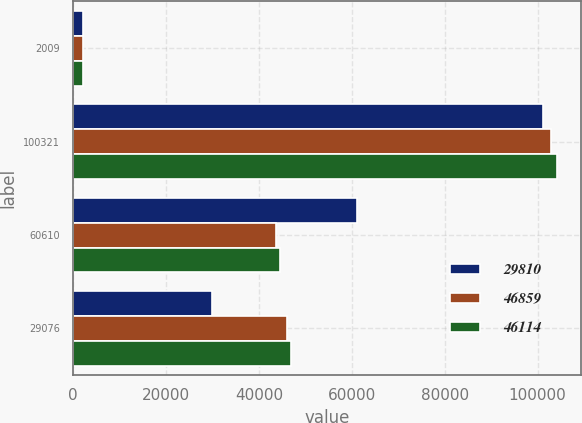Convert chart. <chart><loc_0><loc_0><loc_500><loc_500><stacked_bar_chart><ecel><fcel>2009<fcel>100321<fcel>60610<fcel>29076<nl><fcel>29810<fcel>2009<fcel>101096<fcel>61121<fcel>29810<nl><fcel>46859<fcel>2008<fcel>102908<fcel>43713<fcel>46114<nl><fcel>46114<fcel>2008<fcel>104126<fcel>44627<fcel>46859<nl></chart> 